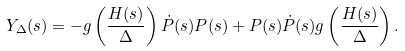Convert formula to latex. <formula><loc_0><loc_0><loc_500><loc_500>Y _ { \Delta } ( s ) = - g \left ( \frac { H ( s ) } { \Delta } \right ) \dot { P } ( s ) P ( s ) + P ( s ) \dot { P } ( s ) g \left ( \frac { H ( s ) } { \Delta } \right ) .</formula> 